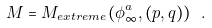Convert formula to latex. <formula><loc_0><loc_0><loc_500><loc_500>M = M _ { e x t r e m e } ( \phi _ { \infty } ^ { a } , ( p , q ) ) \ .</formula> 